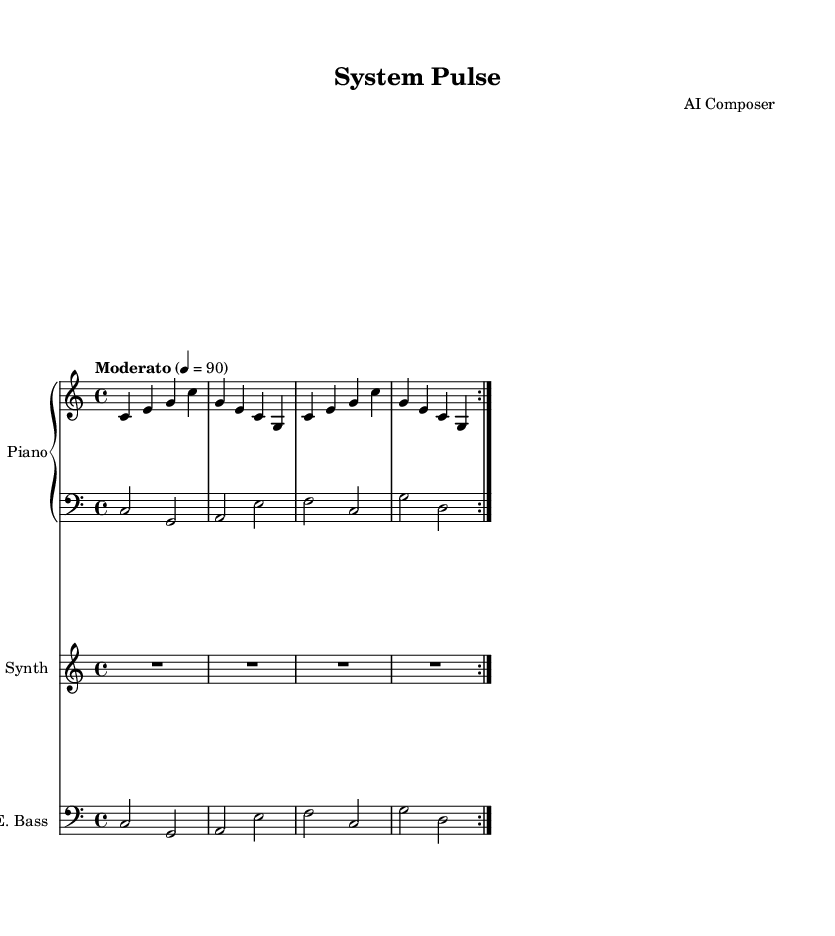What is the key signature of this music? The key signature is C major, which has no sharps or flats indicated in the music sheet. The clefs and notes confirm that it is centered around C major.
Answer: C major What is the time signature of the piece? The time signature is 4/4, which is indicated at the beginning of the score. This means there are four beats per measure.
Answer: 4/4 What is the tempo marking of the composition? The tempo marking is "Moderato" with a tempo of 90 beats per minute, clearly stated above the staff.
Answer: Moderato 4 = 90 How many measures are in the piano part? The piano part contains 8 measures, which is evident through the repeat indication of 2 voltas and counting the individual measures in the score.
Answer: 8 What is the rhythmic value of the synth part? The rhythmic value of the synth part is a whole note, denoted by the "R1*4" rest, meaning it rests for the entire measure.
Answer: Whole note What is the lowest pitch in the bass part? The lowest pitch in the bass part is C, which is the first note in the bass part, clearly visible in the notation.
Answer: C 